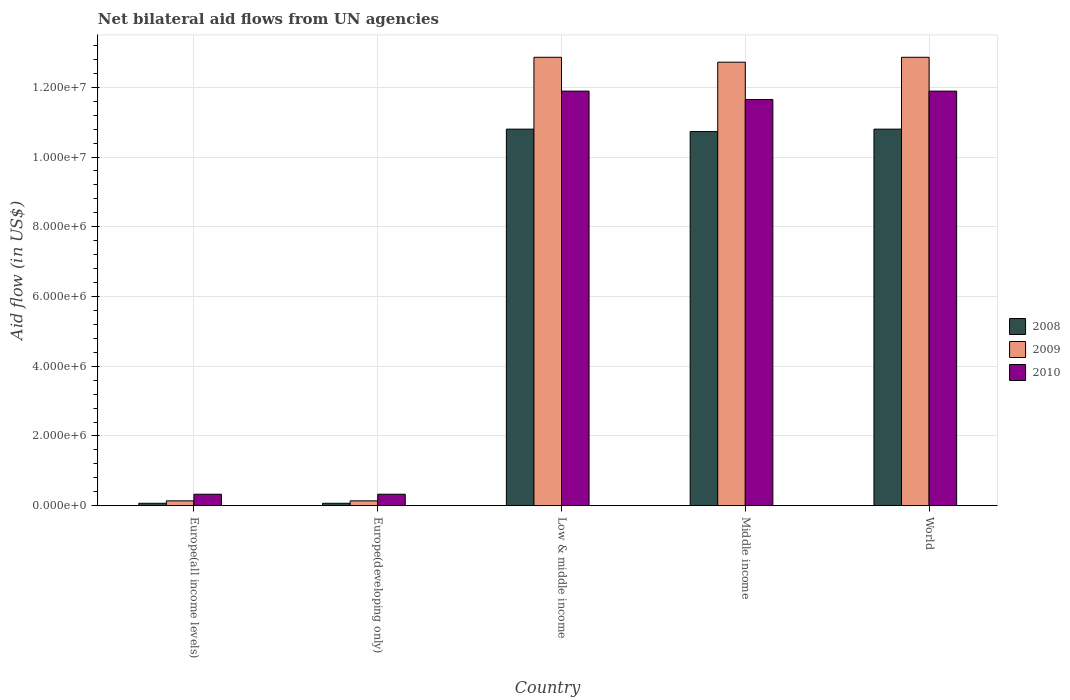How many different coloured bars are there?
Provide a succinct answer. 3. How many groups of bars are there?
Keep it short and to the point. 5. Are the number of bars per tick equal to the number of legend labels?
Your answer should be compact. Yes. How many bars are there on the 3rd tick from the left?
Provide a succinct answer. 3. How many bars are there on the 2nd tick from the right?
Make the answer very short. 3. What is the label of the 4th group of bars from the left?
Your response must be concise. Middle income. In how many cases, is the number of bars for a given country not equal to the number of legend labels?
Offer a very short reply. 0. What is the net bilateral aid flow in 2010 in Europe(developing only)?
Make the answer very short. 3.30e+05. Across all countries, what is the maximum net bilateral aid flow in 2010?
Keep it short and to the point. 1.19e+07. In which country was the net bilateral aid flow in 2010 minimum?
Make the answer very short. Europe(all income levels). What is the total net bilateral aid flow in 2008 in the graph?
Ensure brevity in your answer.  3.25e+07. What is the difference between the net bilateral aid flow in 2010 in Europe(all income levels) and that in Low & middle income?
Provide a succinct answer. -1.16e+07. What is the difference between the net bilateral aid flow in 2010 in Low & middle income and the net bilateral aid flow in 2008 in Europe(developing only)?
Offer a very short reply. 1.18e+07. What is the average net bilateral aid flow in 2010 per country?
Your response must be concise. 7.22e+06. What is the difference between the net bilateral aid flow of/in 2009 and net bilateral aid flow of/in 2010 in World?
Keep it short and to the point. 9.70e+05. What is the ratio of the net bilateral aid flow in 2008 in Europe(developing only) to that in Low & middle income?
Your answer should be compact. 0.01. Is the net bilateral aid flow in 2008 in Europe(all income levels) less than that in Europe(developing only)?
Offer a very short reply. No. Is the difference between the net bilateral aid flow in 2009 in Europe(all income levels) and Europe(developing only) greater than the difference between the net bilateral aid flow in 2010 in Europe(all income levels) and Europe(developing only)?
Your response must be concise. No. What is the difference between the highest and the lowest net bilateral aid flow in 2008?
Provide a short and direct response. 1.07e+07. In how many countries, is the net bilateral aid flow in 2008 greater than the average net bilateral aid flow in 2008 taken over all countries?
Keep it short and to the point. 3. What does the 2nd bar from the right in Middle income represents?
Keep it short and to the point. 2009. How many bars are there?
Provide a short and direct response. 15. How many countries are there in the graph?
Make the answer very short. 5. Are the values on the major ticks of Y-axis written in scientific E-notation?
Offer a terse response. Yes. Does the graph contain any zero values?
Offer a very short reply. No. Where does the legend appear in the graph?
Your answer should be very brief. Center right. How are the legend labels stacked?
Offer a terse response. Vertical. What is the title of the graph?
Your answer should be very brief. Net bilateral aid flows from UN agencies. Does "2009" appear as one of the legend labels in the graph?
Provide a short and direct response. Yes. What is the label or title of the X-axis?
Provide a short and direct response. Country. What is the label or title of the Y-axis?
Offer a very short reply. Aid flow (in US$). What is the Aid flow (in US$) of 2008 in Europe(all income levels)?
Provide a succinct answer. 7.00e+04. What is the Aid flow (in US$) in 2009 in Europe(all income levels)?
Provide a succinct answer. 1.40e+05. What is the Aid flow (in US$) of 2008 in Europe(developing only)?
Provide a succinct answer. 7.00e+04. What is the Aid flow (in US$) of 2009 in Europe(developing only)?
Your response must be concise. 1.40e+05. What is the Aid flow (in US$) in 2008 in Low & middle income?
Keep it short and to the point. 1.08e+07. What is the Aid flow (in US$) in 2009 in Low & middle income?
Offer a terse response. 1.29e+07. What is the Aid flow (in US$) of 2010 in Low & middle income?
Your response must be concise. 1.19e+07. What is the Aid flow (in US$) of 2008 in Middle income?
Your response must be concise. 1.07e+07. What is the Aid flow (in US$) of 2009 in Middle income?
Keep it short and to the point. 1.27e+07. What is the Aid flow (in US$) in 2010 in Middle income?
Keep it short and to the point. 1.16e+07. What is the Aid flow (in US$) of 2008 in World?
Ensure brevity in your answer.  1.08e+07. What is the Aid flow (in US$) in 2009 in World?
Your answer should be very brief. 1.29e+07. What is the Aid flow (in US$) in 2010 in World?
Give a very brief answer. 1.19e+07. Across all countries, what is the maximum Aid flow (in US$) in 2008?
Keep it short and to the point. 1.08e+07. Across all countries, what is the maximum Aid flow (in US$) of 2009?
Provide a succinct answer. 1.29e+07. Across all countries, what is the maximum Aid flow (in US$) in 2010?
Keep it short and to the point. 1.19e+07. What is the total Aid flow (in US$) of 2008 in the graph?
Provide a succinct answer. 3.25e+07. What is the total Aid flow (in US$) in 2009 in the graph?
Provide a succinct answer. 3.87e+07. What is the total Aid flow (in US$) of 2010 in the graph?
Keep it short and to the point. 3.61e+07. What is the difference between the Aid flow (in US$) of 2008 in Europe(all income levels) and that in Europe(developing only)?
Ensure brevity in your answer.  0. What is the difference between the Aid flow (in US$) in 2008 in Europe(all income levels) and that in Low & middle income?
Give a very brief answer. -1.07e+07. What is the difference between the Aid flow (in US$) of 2009 in Europe(all income levels) and that in Low & middle income?
Provide a short and direct response. -1.27e+07. What is the difference between the Aid flow (in US$) in 2010 in Europe(all income levels) and that in Low & middle income?
Offer a terse response. -1.16e+07. What is the difference between the Aid flow (in US$) in 2008 in Europe(all income levels) and that in Middle income?
Keep it short and to the point. -1.07e+07. What is the difference between the Aid flow (in US$) in 2009 in Europe(all income levels) and that in Middle income?
Offer a very short reply. -1.26e+07. What is the difference between the Aid flow (in US$) in 2010 in Europe(all income levels) and that in Middle income?
Your answer should be compact. -1.13e+07. What is the difference between the Aid flow (in US$) of 2008 in Europe(all income levels) and that in World?
Give a very brief answer. -1.07e+07. What is the difference between the Aid flow (in US$) in 2009 in Europe(all income levels) and that in World?
Keep it short and to the point. -1.27e+07. What is the difference between the Aid flow (in US$) in 2010 in Europe(all income levels) and that in World?
Give a very brief answer. -1.16e+07. What is the difference between the Aid flow (in US$) of 2008 in Europe(developing only) and that in Low & middle income?
Make the answer very short. -1.07e+07. What is the difference between the Aid flow (in US$) in 2009 in Europe(developing only) and that in Low & middle income?
Keep it short and to the point. -1.27e+07. What is the difference between the Aid flow (in US$) of 2010 in Europe(developing only) and that in Low & middle income?
Provide a succinct answer. -1.16e+07. What is the difference between the Aid flow (in US$) of 2008 in Europe(developing only) and that in Middle income?
Give a very brief answer. -1.07e+07. What is the difference between the Aid flow (in US$) in 2009 in Europe(developing only) and that in Middle income?
Make the answer very short. -1.26e+07. What is the difference between the Aid flow (in US$) of 2010 in Europe(developing only) and that in Middle income?
Your response must be concise. -1.13e+07. What is the difference between the Aid flow (in US$) of 2008 in Europe(developing only) and that in World?
Your response must be concise. -1.07e+07. What is the difference between the Aid flow (in US$) of 2009 in Europe(developing only) and that in World?
Provide a succinct answer. -1.27e+07. What is the difference between the Aid flow (in US$) of 2010 in Europe(developing only) and that in World?
Make the answer very short. -1.16e+07. What is the difference between the Aid flow (in US$) of 2008 in Low & middle income and that in World?
Make the answer very short. 0. What is the difference between the Aid flow (in US$) in 2009 in Low & middle income and that in World?
Provide a short and direct response. 0. What is the difference between the Aid flow (in US$) in 2010 in Low & middle income and that in World?
Offer a very short reply. 0. What is the difference between the Aid flow (in US$) in 2009 in Middle income and that in World?
Offer a very short reply. -1.40e+05. What is the difference between the Aid flow (in US$) of 2008 in Europe(all income levels) and the Aid flow (in US$) of 2009 in Europe(developing only)?
Ensure brevity in your answer.  -7.00e+04. What is the difference between the Aid flow (in US$) in 2008 in Europe(all income levels) and the Aid flow (in US$) in 2010 in Europe(developing only)?
Offer a terse response. -2.60e+05. What is the difference between the Aid flow (in US$) of 2009 in Europe(all income levels) and the Aid flow (in US$) of 2010 in Europe(developing only)?
Keep it short and to the point. -1.90e+05. What is the difference between the Aid flow (in US$) of 2008 in Europe(all income levels) and the Aid flow (in US$) of 2009 in Low & middle income?
Make the answer very short. -1.28e+07. What is the difference between the Aid flow (in US$) in 2008 in Europe(all income levels) and the Aid flow (in US$) in 2010 in Low & middle income?
Your answer should be very brief. -1.18e+07. What is the difference between the Aid flow (in US$) in 2009 in Europe(all income levels) and the Aid flow (in US$) in 2010 in Low & middle income?
Offer a terse response. -1.18e+07. What is the difference between the Aid flow (in US$) of 2008 in Europe(all income levels) and the Aid flow (in US$) of 2009 in Middle income?
Make the answer very short. -1.26e+07. What is the difference between the Aid flow (in US$) of 2008 in Europe(all income levels) and the Aid flow (in US$) of 2010 in Middle income?
Provide a short and direct response. -1.16e+07. What is the difference between the Aid flow (in US$) in 2009 in Europe(all income levels) and the Aid flow (in US$) in 2010 in Middle income?
Keep it short and to the point. -1.15e+07. What is the difference between the Aid flow (in US$) in 2008 in Europe(all income levels) and the Aid flow (in US$) in 2009 in World?
Ensure brevity in your answer.  -1.28e+07. What is the difference between the Aid flow (in US$) in 2008 in Europe(all income levels) and the Aid flow (in US$) in 2010 in World?
Provide a succinct answer. -1.18e+07. What is the difference between the Aid flow (in US$) in 2009 in Europe(all income levels) and the Aid flow (in US$) in 2010 in World?
Make the answer very short. -1.18e+07. What is the difference between the Aid flow (in US$) of 2008 in Europe(developing only) and the Aid flow (in US$) of 2009 in Low & middle income?
Make the answer very short. -1.28e+07. What is the difference between the Aid flow (in US$) in 2008 in Europe(developing only) and the Aid flow (in US$) in 2010 in Low & middle income?
Give a very brief answer. -1.18e+07. What is the difference between the Aid flow (in US$) of 2009 in Europe(developing only) and the Aid flow (in US$) of 2010 in Low & middle income?
Your response must be concise. -1.18e+07. What is the difference between the Aid flow (in US$) in 2008 in Europe(developing only) and the Aid flow (in US$) in 2009 in Middle income?
Keep it short and to the point. -1.26e+07. What is the difference between the Aid flow (in US$) of 2008 in Europe(developing only) and the Aid flow (in US$) of 2010 in Middle income?
Make the answer very short. -1.16e+07. What is the difference between the Aid flow (in US$) in 2009 in Europe(developing only) and the Aid flow (in US$) in 2010 in Middle income?
Give a very brief answer. -1.15e+07. What is the difference between the Aid flow (in US$) of 2008 in Europe(developing only) and the Aid flow (in US$) of 2009 in World?
Ensure brevity in your answer.  -1.28e+07. What is the difference between the Aid flow (in US$) of 2008 in Europe(developing only) and the Aid flow (in US$) of 2010 in World?
Provide a short and direct response. -1.18e+07. What is the difference between the Aid flow (in US$) of 2009 in Europe(developing only) and the Aid flow (in US$) of 2010 in World?
Give a very brief answer. -1.18e+07. What is the difference between the Aid flow (in US$) in 2008 in Low & middle income and the Aid flow (in US$) in 2009 in Middle income?
Your answer should be very brief. -1.92e+06. What is the difference between the Aid flow (in US$) in 2008 in Low & middle income and the Aid flow (in US$) in 2010 in Middle income?
Offer a terse response. -8.50e+05. What is the difference between the Aid flow (in US$) in 2009 in Low & middle income and the Aid flow (in US$) in 2010 in Middle income?
Give a very brief answer. 1.21e+06. What is the difference between the Aid flow (in US$) of 2008 in Low & middle income and the Aid flow (in US$) of 2009 in World?
Ensure brevity in your answer.  -2.06e+06. What is the difference between the Aid flow (in US$) of 2008 in Low & middle income and the Aid flow (in US$) of 2010 in World?
Offer a terse response. -1.09e+06. What is the difference between the Aid flow (in US$) of 2009 in Low & middle income and the Aid flow (in US$) of 2010 in World?
Offer a very short reply. 9.70e+05. What is the difference between the Aid flow (in US$) in 2008 in Middle income and the Aid flow (in US$) in 2009 in World?
Provide a short and direct response. -2.13e+06. What is the difference between the Aid flow (in US$) of 2008 in Middle income and the Aid flow (in US$) of 2010 in World?
Provide a succinct answer. -1.16e+06. What is the difference between the Aid flow (in US$) in 2009 in Middle income and the Aid flow (in US$) in 2010 in World?
Your response must be concise. 8.30e+05. What is the average Aid flow (in US$) in 2008 per country?
Provide a short and direct response. 6.49e+06. What is the average Aid flow (in US$) of 2009 per country?
Ensure brevity in your answer.  7.74e+06. What is the average Aid flow (in US$) in 2010 per country?
Ensure brevity in your answer.  7.22e+06. What is the difference between the Aid flow (in US$) in 2008 and Aid flow (in US$) in 2009 in Europe(all income levels)?
Your answer should be compact. -7.00e+04. What is the difference between the Aid flow (in US$) in 2008 and Aid flow (in US$) in 2009 in Low & middle income?
Make the answer very short. -2.06e+06. What is the difference between the Aid flow (in US$) in 2008 and Aid flow (in US$) in 2010 in Low & middle income?
Your response must be concise. -1.09e+06. What is the difference between the Aid flow (in US$) in 2009 and Aid flow (in US$) in 2010 in Low & middle income?
Your answer should be very brief. 9.70e+05. What is the difference between the Aid flow (in US$) of 2008 and Aid flow (in US$) of 2009 in Middle income?
Ensure brevity in your answer.  -1.99e+06. What is the difference between the Aid flow (in US$) in 2008 and Aid flow (in US$) in 2010 in Middle income?
Offer a very short reply. -9.20e+05. What is the difference between the Aid flow (in US$) in 2009 and Aid flow (in US$) in 2010 in Middle income?
Provide a short and direct response. 1.07e+06. What is the difference between the Aid flow (in US$) in 2008 and Aid flow (in US$) in 2009 in World?
Your response must be concise. -2.06e+06. What is the difference between the Aid flow (in US$) in 2008 and Aid flow (in US$) in 2010 in World?
Ensure brevity in your answer.  -1.09e+06. What is the difference between the Aid flow (in US$) in 2009 and Aid flow (in US$) in 2010 in World?
Provide a succinct answer. 9.70e+05. What is the ratio of the Aid flow (in US$) of 2008 in Europe(all income levels) to that in Europe(developing only)?
Offer a very short reply. 1. What is the ratio of the Aid flow (in US$) in 2009 in Europe(all income levels) to that in Europe(developing only)?
Provide a short and direct response. 1. What is the ratio of the Aid flow (in US$) in 2008 in Europe(all income levels) to that in Low & middle income?
Ensure brevity in your answer.  0.01. What is the ratio of the Aid flow (in US$) in 2009 in Europe(all income levels) to that in Low & middle income?
Give a very brief answer. 0.01. What is the ratio of the Aid flow (in US$) of 2010 in Europe(all income levels) to that in Low & middle income?
Give a very brief answer. 0.03. What is the ratio of the Aid flow (in US$) in 2008 in Europe(all income levels) to that in Middle income?
Your answer should be compact. 0.01. What is the ratio of the Aid flow (in US$) in 2009 in Europe(all income levels) to that in Middle income?
Make the answer very short. 0.01. What is the ratio of the Aid flow (in US$) of 2010 in Europe(all income levels) to that in Middle income?
Your response must be concise. 0.03. What is the ratio of the Aid flow (in US$) of 2008 in Europe(all income levels) to that in World?
Your answer should be compact. 0.01. What is the ratio of the Aid flow (in US$) of 2009 in Europe(all income levels) to that in World?
Your response must be concise. 0.01. What is the ratio of the Aid flow (in US$) of 2010 in Europe(all income levels) to that in World?
Offer a very short reply. 0.03. What is the ratio of the Aid flow (in US$) in 2008 in Europe(developing only) to that in Low & middle income?
Keep it short and to the point. 0.01. What is the ratio of the Aid flow (in US$) in 2009 in Europe(developing only) to that in Low & middle income?
Offer a terse response. 0.01. What is the ratio of the Aid flow (in US$) in 2010 in Europe(developing only) to that in Low & middle income?
Your answer should be very brief. 0.03. What is the ratio of the Aid flow (in US$) in 2008 in Europe(developing only) to that in Middle income?
Your response must be concise. 0.01. What is the ratio of the Aid flow (in US$) of 2009 in Europe(developing only) to that in Middle income?
Keep it short and to the point. 0.01. What is the ratio of the Aid flow (in US$) in 2010 in Europe(developing only) to that in Middle income?
Provide a succinct answer. 0.03. What is the ratio of the Aid flow (in US$) in 2008 in Europe(developing only) to that in World?
Your response must be concise. 0.01. What is the ratio of the Aid flow (in US$) in 2009 in Europe(developing only) to that in World?
Ensure brevity in your answer.  0.01. What is the ratio of the Aid flow (in US$) of 2010 in Europe(developing only) to that in World?
Offer a very short reply. 0.03. What is the ratio of the Aid flow (in US$) in 2009 in Low & middle income to that in Middle income?
Provide a succinct answer. 1.01. What is the ratio of the Aid flow (in US$) in 2010 in Low & middle income to that in Middle income?
Your answer should be very brief. 1.02. What is the ratio of the Aid flow (in US$) of 2008 in Low & middle income to that in World?
Give a very brief answer. 1. What is the ratio of the Aid flow (in US$) of 2009 in Low & middle income to that in World?
Offer a very short reply. 1. What is the ratio of the Aid flow (in US$) of 2010 in Low & middle income to that in World?
Your answer should be compact. 1. What is the ratio of the Aid flow (in US$) in 2010 in Middle income to that in World?
Your answer should be very brief. 0.98. What is the difference between the highest and the second highest Aid flow (in US$) of 2009?
Your answer should be very brief. 0. What is the difference between the highest and the lowest Aid flow (in US$) of 2008?
Keep it short and to the point. 1.07e+07. What is the difference between the highest and the lowest Aid flow (in US$) in 2009?
Your answer should be compact. 1.27e+07. What is the difference between the highest and the lowest Aid flow (in US$) in 2010?
Your answer should be compact. 1.16e+07. 